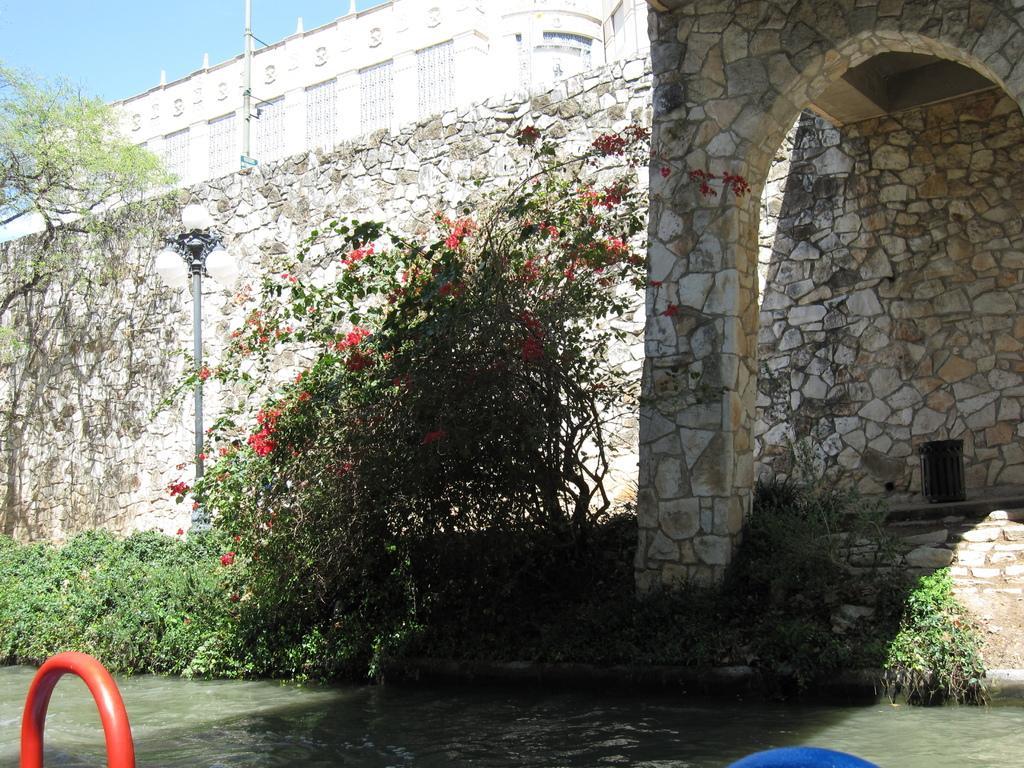Could you give a brief overview of what you see in this image? In this image we can see the building, light poles, trees, creepers, fencing wall and also the water at the bottom. We can also see the sky and some other objects. 